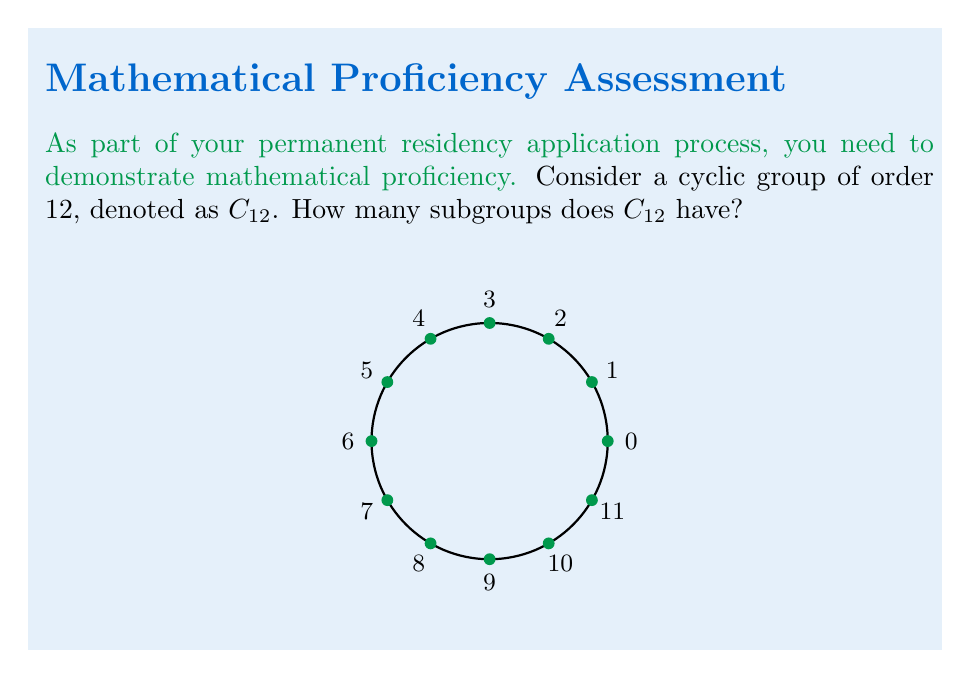Can you solve this math problem? To find the number of subgroups in $C_{12}$, we can follow these steps:

1) Recall that the subgroups of a cyclic group are precisely the cyclic subgroups generated by its elements.

2) In a cyclic group of order n, the order of an element divides n. The divisors of 12 are 1, 2, 3, 4, 6, and 12.

3) For each divisor d of 12, there is a unique subgroup of order d. This is because:
   $$\langle a^k \rangle = \langle a^{\gcd(k,12)} \rangle$$

4) Therefore, we just need to count the number of divisors of 12:
   - 1 subgroup of order 1 (the trivial subgroup)
   - 1 subgroup of order 2
   - 1 subgroup of order 3
   - 1 subgroup of order 4
   - 1 subgroup of order 6
   - 1 subgroup of order 12 (the whole group)

5) In total, we have 6 subgroups, one for each divisor of 12.

This result generalizes: for any cyclic group $C_n$, the number of subgroups is equal to the number of divisors of n.
Answer: 6 